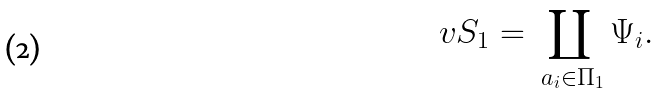<formula> <loc_0><loc_0><loc_500><loc_500>\ v S _ { 1 } = \coprod _ { \ a _ { i } \in \Pi _ { 1 } } \Psi _ { i } .</formula> 